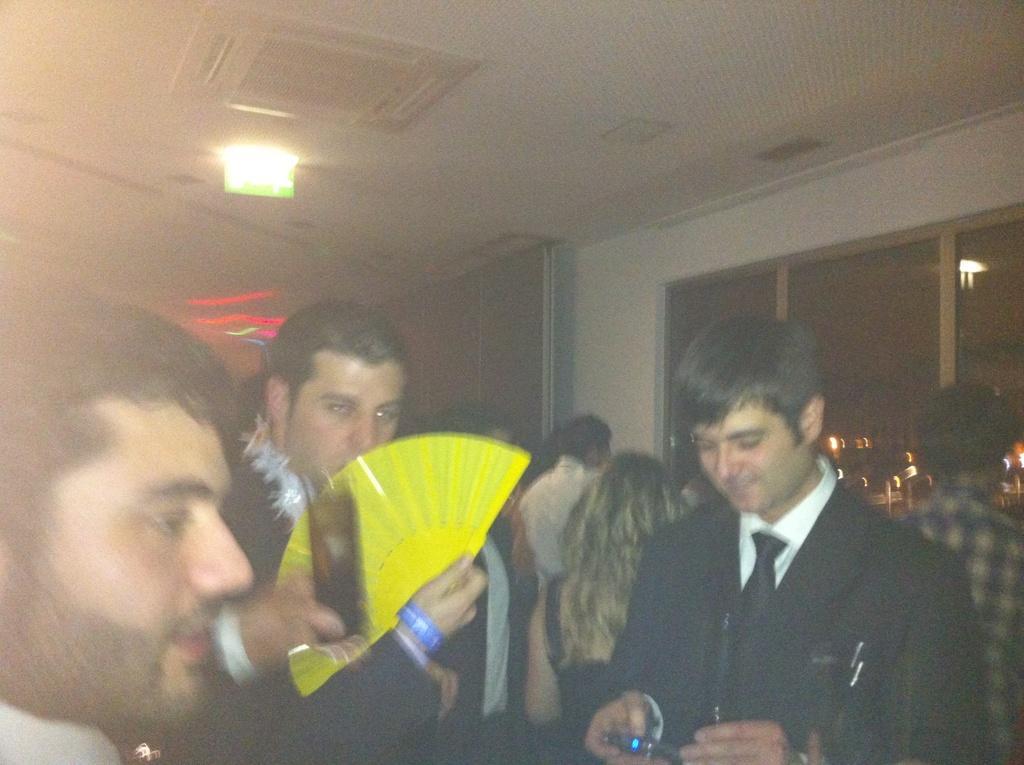How would you summarize this image in a sentence or two? This picture shows few people standing and we see a man holding a hand fan in his hand and another man holding a glass and we see another man holding a mobile in his hand and we see light to the ceiling and air conditioner. 